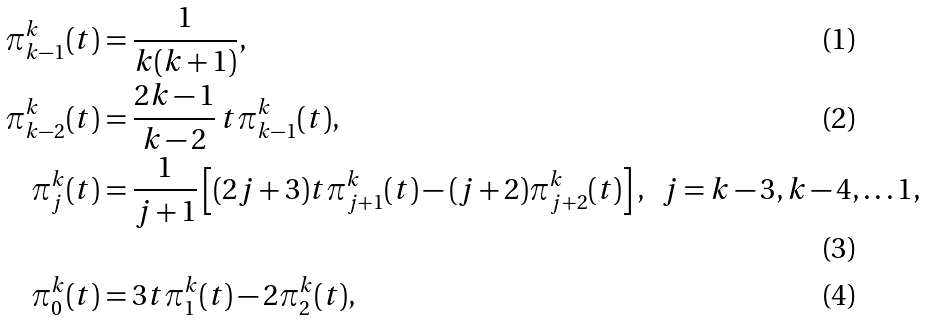Convert formula to latex. <formula><loc_0><loc_0><loc_500><loc_500>\pi _ { k - 1 } ^ { k } ( t ) & = \frac { 1 } { k ( k + 1 ) } , \\ \pi _ { k - 2 } ^ { k } ( t ) & = \frac { 2 k - 1 } { k - 2 } \, t \pi _ { k - 1 } ^ { k } ( t ) , \\ \pi _ { j } ^ { k } ( t ) & = \frac { 1 } { j + 1 } \left [ ( 2 j + 3 ) t \pi _ { j + 1 } ^ { k } ( t ) - ( j + 2 ) \pi _ { j + 2 } ^ { k } ( t ) \right ] , & j = k - 3 , k - 4 , \dots 1 , \\ \pi _ { 0 } ^ { k } ( t ) & = 3 t \pi _ { 1 } ^ { k } ( t ) - 2 \pi _ { 2 } ^ { k } ( t ) ,</formula> 